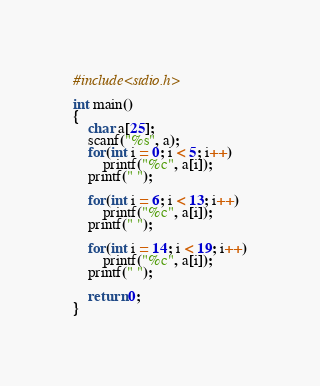Convert code to text. <code><loc_0><loc_0><loc_500><loc_500><_C_>#include<stdio.h>

int main()
{
	char a[25];
	scanf("%s", a);
	for(int i = 0; i < 5; i++)
		printf("%c", a[i]);
	printf(" ");
	
	for(int i = 6; i < 13; i++)
		printf("%c", a[i]);
	printf(" ");
	
	for(int i = 14; i < 19; i++)
		printf("%c", a[i]);
	printf(" ");
	
	return 0;
}</code> 